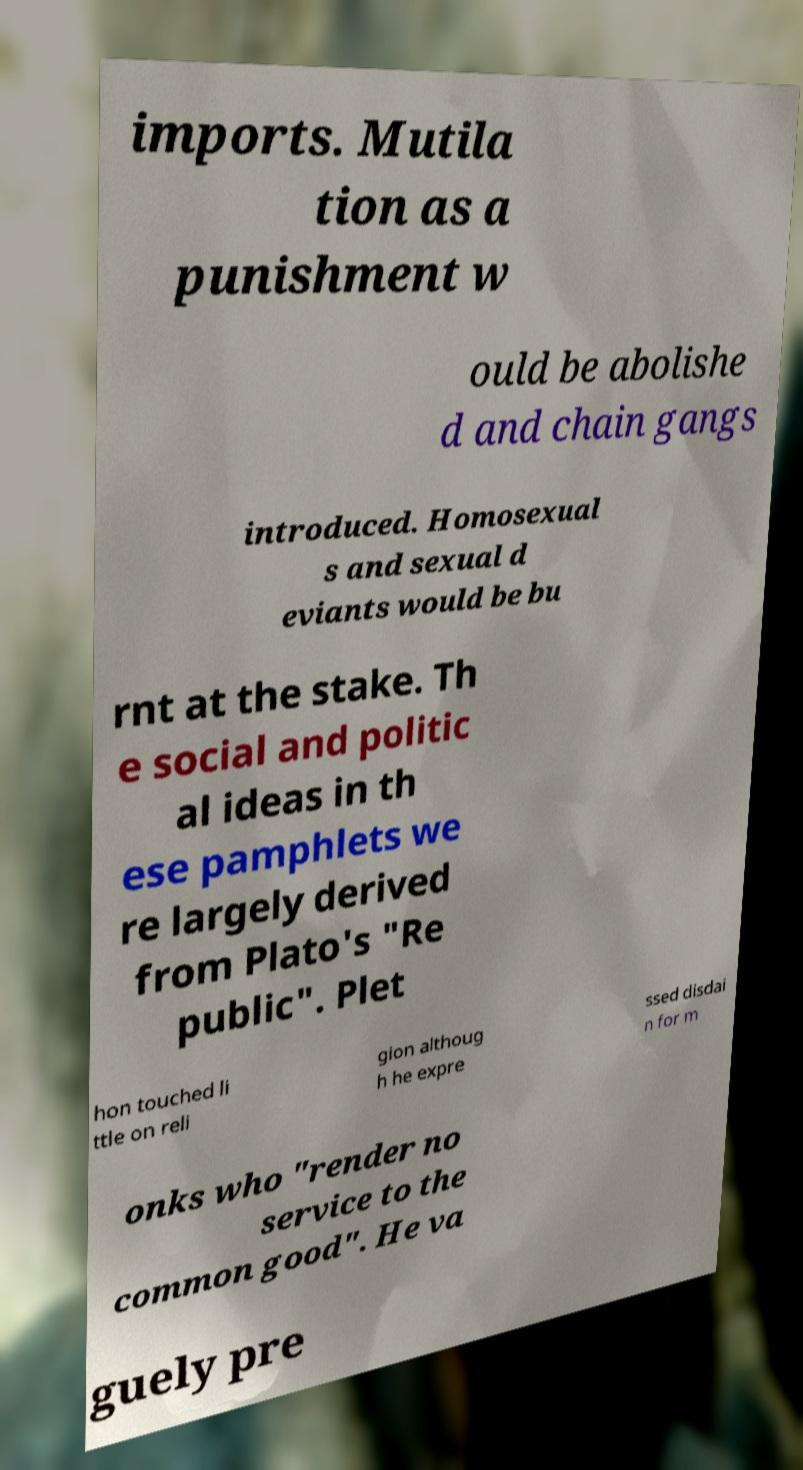Could you assist in decoding the text presented in this image and type it out clearly? imports. Mutila tion as a punishment w ould be abolishe d and chain gangs introduced. Homosexual s and sexual d eviants would be bu rnt at the stake. Th e social and politic al ideas in th ese pamphlets we re largely derived from Plato's "Re public". Plet hon touched li ttle on reli gion althoug h he expre ssed disdai n for m onks who "render no service to the common good". He va guely pre 